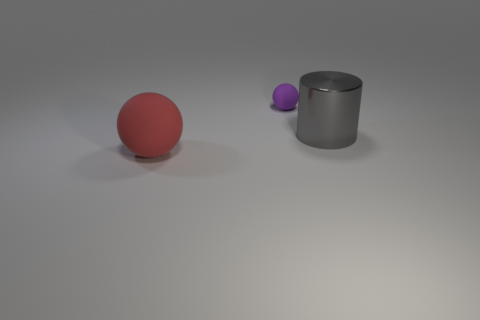Add 3 small red metal cylinders. How many objects exist? 6 Subtract all cylinders. How many objects are left? 2 Subtract all gray blocks. How many purple spheres are left? 1 Add 1 metal objects. How many metal objects are left? 2 Add 3 red shiny cylinders. How many red shiny cylinders exist? 3 Subtract 0 green cylinders. How many objects are left? 3 Subtract all gray spheres. Subtract all purple blocks. How many spheres are left? 2 Subtract all blue rubber cubes. Subtract all red balls. How many objects are left? 2 